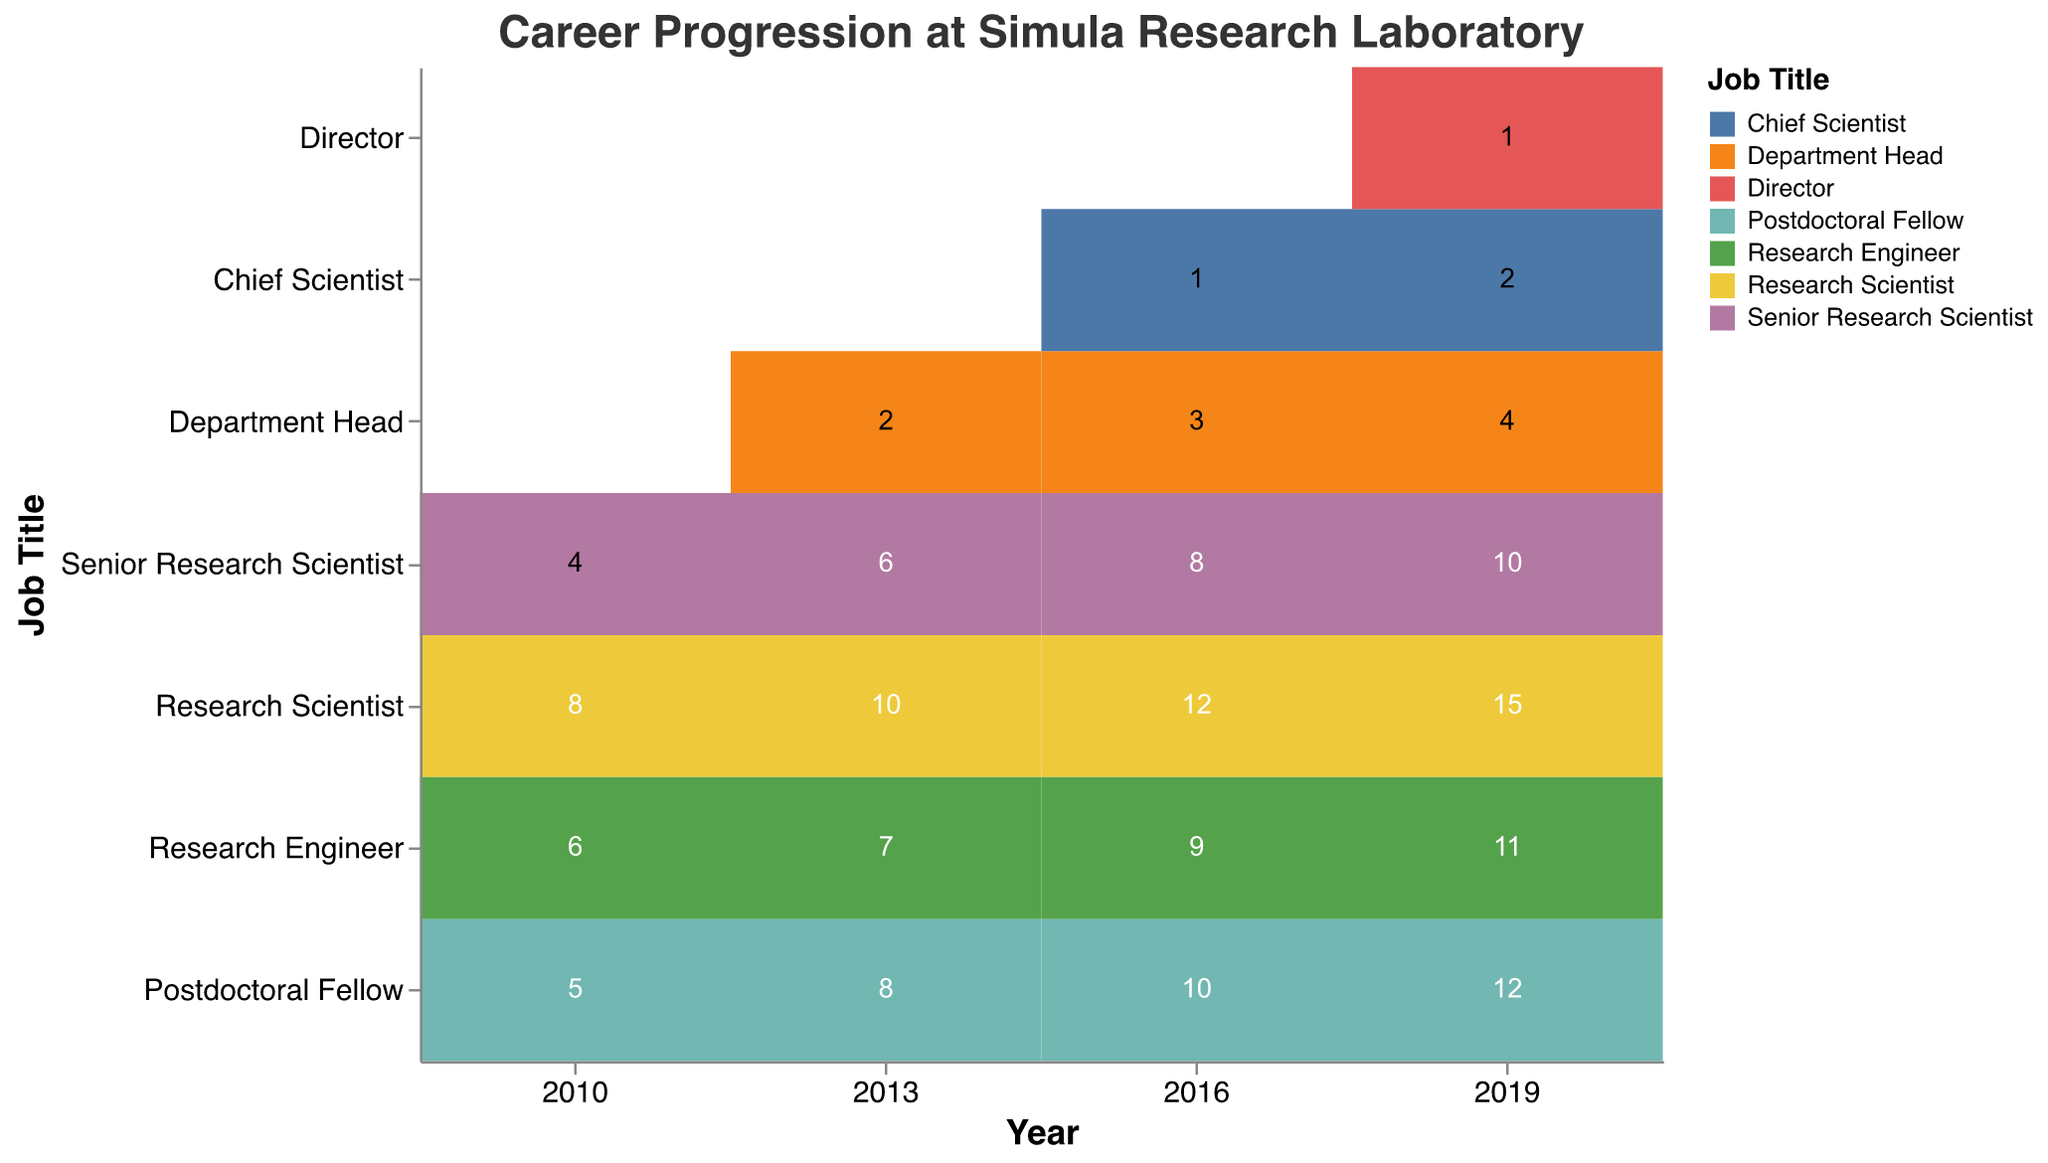What is the title of the plot? The plot title can be seen at the top of the figure, displaying the text: "Career Progression at Simula Research Laboratory".
Answer: Career Progression at Simula Research Laboratory How many job titles are shown in the year 2010? By referring to the y-axis and visually inspecting the job titles for the year 2010, we can count them.
Answer: 4 Which job title has the highest count in 2019? Inspect the cells and their count text in the figure for the year 2019. The highest count corresponds to the "Research Scientist" title.
Answer: Research Scientist What is the trend in the number of Senior Research Scientists from 2010 to 2019? To determine the trend, compare the counts visually for the years 2010, 2013, 2016, and 2019. The counts are 4, 6, 8, and 10, respectively, showing an increasing trend.
Answer: Increasing Which year introduced new job titles compared to 2010 and what are they? Compare the job titles present in 2013, 2016, and 2019 with those in 2010. In 2013, "Department Head" was introduced, in 2016 "Chief Scientist" was introduced and in 2019 "Director" was introduced.
Answer: 2013 (Department Head), 2016 (Chief Scientist), 2019 (Director) How has the count of Postdoctoral Fellows changed from 2010 to 2019? Observe the counts for the "Postdoctoral Fellow" title in years 2010, 2013, 2016, and 2019. The counts are 5, 8, 10, and 12 respectively, indicating an increasing trend.
Answer: Increased Compare the count of Research Engineers in 2013 and 2016. Which year had more, and by how much? Check the counts for the "Research Engineer" title for the years 2013 and 2016. The counts are 7 and 9 respectively. The difference is 2.
Answer: 2016 by 2 What is the total number of employees across all job titles in 2016? Sum the counts of all the job titles for the year 2016: 12 + 8 + 9 + 10 + 3 + 1. The total is 43.
Answer: 43 Which job title had the smallest count in 2016 and what was it? Find the job title with the smallest count by looking at the counts for each title in 2016. "Chief Scientist" has the smallest count with 1.
Answer: Chief Scientist, 1 How many different job titles are present in the data for the year 2019? By referring to the y-axis and visually inspecting the job titles for the year 2019, we count them.
Answer: 7 